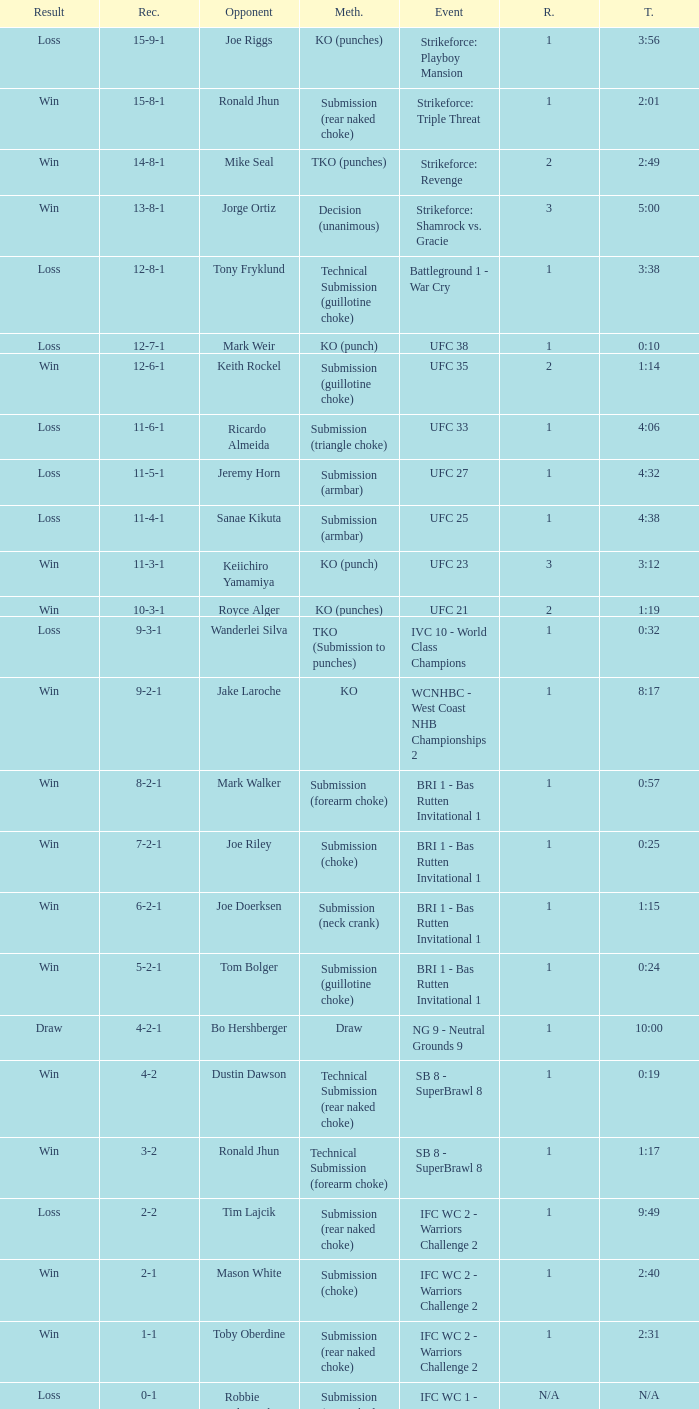Who was the opponent when the fight had a time of 0:10? Mark Weir. 